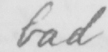What text is written in this handwritten line? bad 